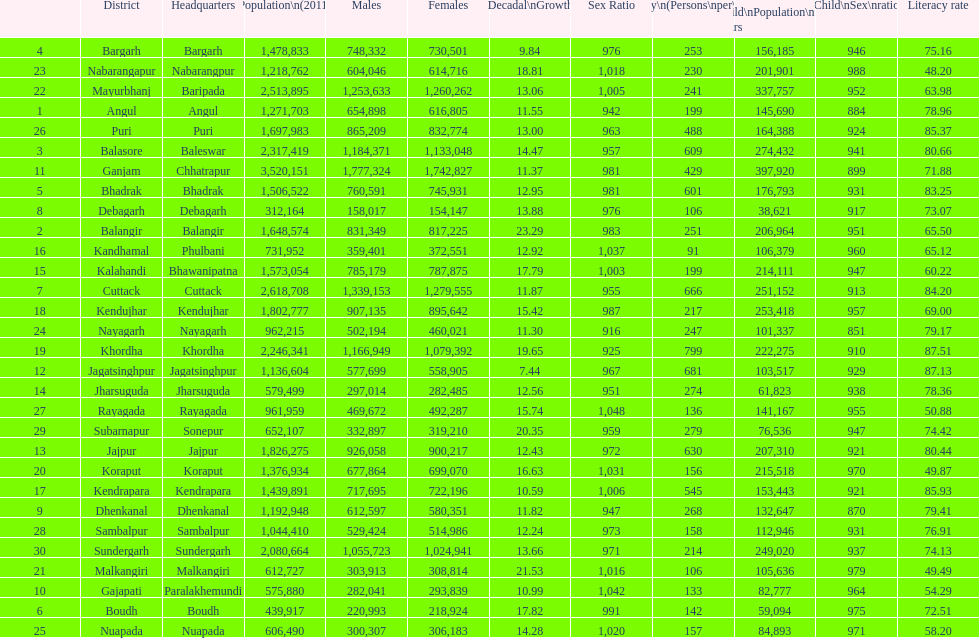How many districts have experienced over 15% decadal growth in percentage? 10. Would you mind parsing the complete table? {'header': ['', 'District', 'Headquarters', 'Population\\n(2011)', 'Males', 'Females', 'Percentage\\nDecadal\\nGrowth\\n2001-2011', 'Sex Ratio', 'Density\\n(Persons\\nper\\nkm2)', 'Child\\nPopulation\\n0–6 years', 'Child\\nSex\\nratio', 'Literacy rate'], 'rows': [['4', 'Bargarh', 'Bargarh', '1,478,833', '748,332', '730,501', '9.84', '976', '253', '156,185', '946', '75.16'], ['23', 'Nabarangapur', 'Nabarangpur', '1,218,762', '604,046', '614,716', '18.81', '1,018', '230', '201,901', '988', '48.20'], ['22', 'Mayurbhanj', 'Baripada', '2,513,895', '1,253,633', '1,260,262', '13.06', '1,005', '241', '337,757', '952', '63.98'], ['1', 'Angul', 'Angul', '1,271,703', '654,898', '616,805', '11.55', '942', '199', '145,690', '884', '78.96'], ['26', 'Puri', 'Puri', '1,697,983', '865,209', '832,774', '13.00', '963', '488', '164,388', '924', '85.37'], ['3', 'Balasore', 'Baleswar', '2,317,419', '1,184,371', '1,133,048', '14.47', '957', '609', '274,432', '941', '80.66'], ['11', 'Ganjam', 'Chhatrapur', '3,520,151', '1,777,324', '1,742,827', '11.37', '981', '429', '397,920', '899', '71.88'], ['5', 'Bhadrak', 'Bhadrak', '1,506,522', '760,591', '745,931', '12.95', '981', '601', '176,793', '931', '83.25'], ['8', 'Debagarh', 'Debagarh', '312,164', '158,017', '154,147', '13.88', '976', '106', '38,621', '917', '73.07'], ['2', 'Balangir', 'Balangir', '1,648,574', '831,349', '817,225', '23.29', '983', '251', '206,964', '951', '65.50'], ['16', 'Kandhamal', 'Phulbani', '731,952', '359,401', '372,551', '12.92', '1,037', '91', '106,379', '960', '65.12'], ['15', 'Kalahandi', 'Bhawanipatna', '1,573,054', '785,179', '787,875', '17.79', '1,003', '199', '214,111', '947', '60.22'], ['7', 'Cuttack', 'Cuttack', '2,618,708', '1,339,153', '1,279,555', '11.87', '955', '666', '251,152', '913', '84.20'], ['18', 'Kendujhar', 'Kendujhar', '1,802,777', '907,135', '895,642', '15.42', '987', '217', '253,418', '957', '69.00'], ['24', 'Nayagarh', 'Nayagarh', '962,215', '502,194', '460,021', '11.30', '916', '247', '101,337', '851', '79.17'], ['19', 'Khordha', 'Khordha', '2,246,341', '1,166,949', '1,079,392', '19.65', '925', '799', '222,275', '910', '87.51'], ['12', 'Jagatsinghpur', 'Jagatsinghpur', '1,136,604', '577,699', '558,905', '7.44', '967', '681', '103,517', '929', '87.13'], ['14', 'Jharsuguda', 'Jharsuguda', '579,499', '297,014', '282,485', '12.56', '951', '274', '61,823', '938', '78.36'], ['27', 'Rayagada', 'Rayagada', '961,959', '469,672', '492,287', '15.74', '1,048', '136', '141,167', '955', '50.88'], ['29', 'Subarnapur', 'Sonepur', '652,107', '332,897', '319,210', '20.35', '959', '279', '76,536', '947', '74.42'], ['13', 'Jajpur', 'Jajpur', '1,826,275', '926,058', '900,217', '12.43', '972', '630', '207,310', '921', '80.44'], ['20', 'Koraput', 'Koraput', '1,376,934', '677,864', '699,070', '16.63', '1,031', '156', '215,518', '970', '49.87'], ['17', 'Kendrapara', 'Kendrapara', '1,439,891', '717,695', '722,196', '10.59', '1,006', '545', '153,443', '921', '85.93'], ['9', 'Dhenkanal', 'Dhenkanal', '1,192,948', '612,597', '580,351', '11.82', '947', '268', '132,647', '870', '79.41'], ['28', 'Sambalpur', 'Sambalpur', '1,044,410', '529,424', '514,986', '12.24', '973', '158', '112,946', '931', '76.91'], ['30', 'Sundergarh', 'Sundergarh', '2,080,664', '1,055,723', '1,024,941', '13.66', '971', '214', '249,020', '937', '74.13'], ['21', 'Malkangiri', 'Malkangiri', '612,727', '303,913', '308,814', '21.53', '1,016', '106', '105,636', '979', '49.49'], ['10', 'Gajapati', 'Paralakhemundi', '575,880', '282,041', '293,839', '10.99', '1,042', '133', '82,777', '964', '54.29'], ['6', 'Boudh', 'Boudh', '439,917', '220,993', '218,924', '17.82', '991', '142', '59,094', '975', '72.51'], ['25', 'Nuapada', 'Nuapada', '606,490', '300,307', '306,183', '14.28', '1,020', '157', '84,893', '971', '58.20']]} 